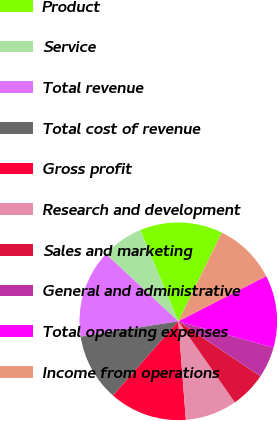<chart> <loc_0><loc_0><loc_500><loc_500><pie_chart><fcel>Product<fcel>Service<fcel>Total revenue<fcel>Total cost of revenue<fcel>Gross profit<fcel>Research and development<fcel>Sales and marketing<fcel>General and administrative<fcel>Total operating expenses<fcel>Income from operations<nl><fcel>13.56%<fcel>6.78%<fcel>14.41%<fcel>11.02%<fcel>12.71%<fcel>8.47%<fcel>5.93%<fcel>5.08%<fcel>11.86%<fcel>10.17%<nl></chart> 